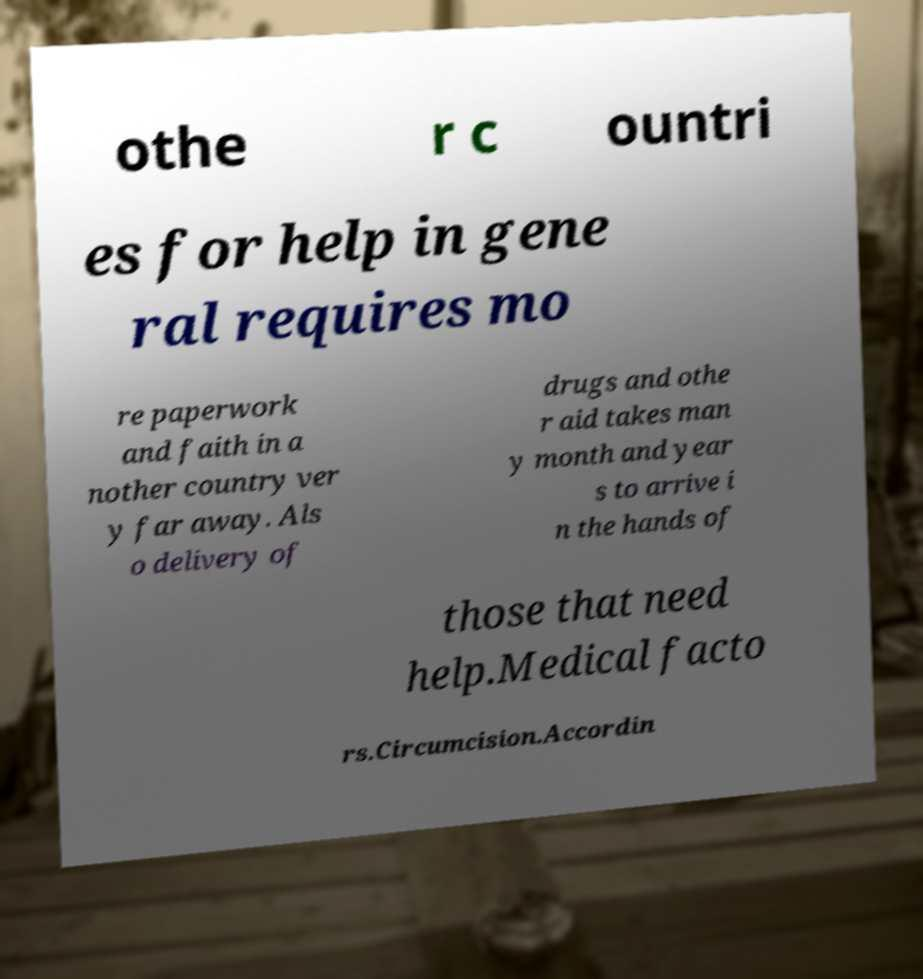Could you extract and type out the text from this image? othe r c ountri es for help in gene ral requires mo re paperwork and faith in a nother country ver y far away. Als o delivery of drugs and othe r aid takes man y month and year s to arrive i n the hands of those that need help.Medical facto rs.Circumcision.Accordin 